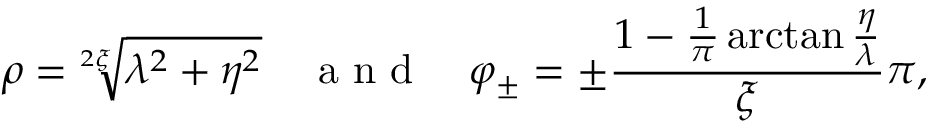<formula> <loc_0><loc_0><loc_500><loc_500>\rho = \sqrt { [ } 2 \xi ] { \lambda ^ { 2 } + \eta ^ { 2 } } \quad a n d \quad \varphi _ { \pm } = \pm \frac { 1 - \frac { 1 } { \pi } \arctan \frac { \eta } { \lambda } } { \xi } \pi ,</formula> 